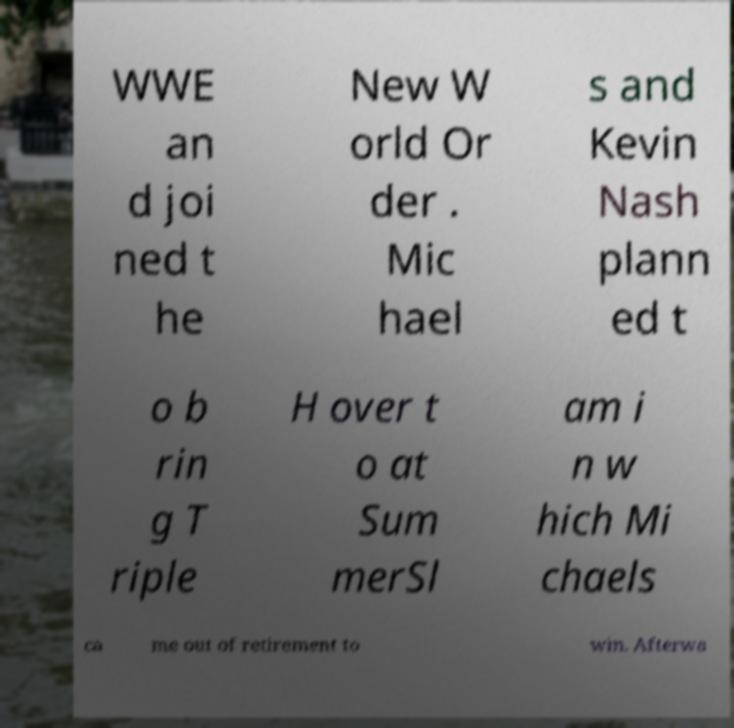What messages or text are displayed in this image? I need them in a readable, typed format. WWE an d joi ned t he New W orld Or der . Mic hael s and Kevin Nash plann ed t o b rin g T riple H over t o at Sum merSl am i n w hich Mi chaels ca me out of retirement to win. Afterwa 